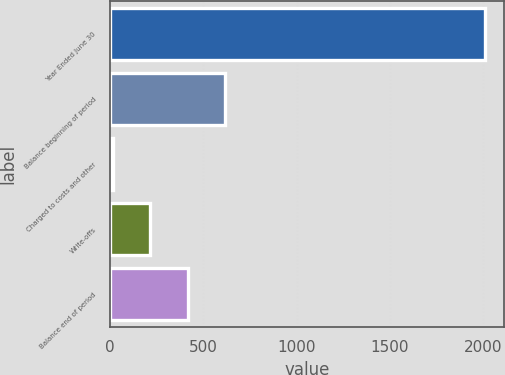<chart> <loc_0><loc_0><loc_500><loc_500><bar_chart><fcel>Year Ended June 30<fcel>Balance beginning of period<fcel>Charged to costs and other<fcel>Write-offs<fcel>Balance end of period<nl><fcel>2014<fcel>615.4<fcel>16<fcel>215.8<fcel>415.6<nl></chart> 